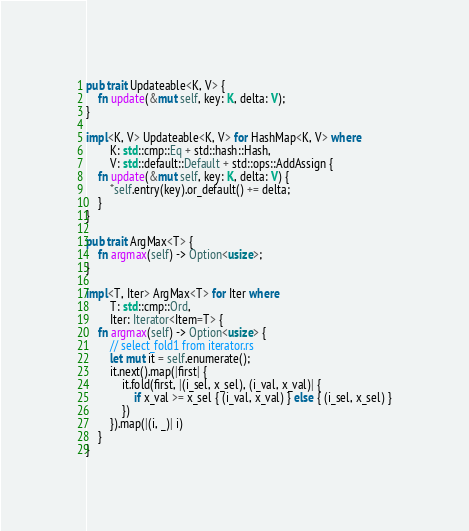Convert code to text. <code><loc_0><loc_0><loc_500><loc_500><_Rust_>
pub trait Updateable<K, V> {
    fn update(&mut self, key: K, delta: V);
}

impl<K, V> Updateable<K, V> for HashMap<K, V> where
        K: std::cmp::Eq + std::hash::Hash,
        V: std::default::Default + std::ops::AddAssign {
    fn update(&mut self, key: K, delta: V) {
        *self.entry(key).or_default() += delta;
    }
}

pub trait ArgMax<T> {
    fn argmax(self) -> Option<usize>;
}

impl<T, Iter> ArgMax<T> for Iter where
        T: std::cmp::Ord,
        Iter: Iterator<Item=T> {
    fn argmax(self) -> Option<usize> {
        // select_fold1 from iterator.rs
        let mut it = self.enumerate();
        it.next().map(|first| {
            it.fold(first, |(i_sel, x_sel), (i_val, x_val)| {
                if x_val >= x_sel { (i_val, x_val) } else { (i_sel, x_sel) }
            })
        }).map(|(i, _)| i)
    }
}
</code> 